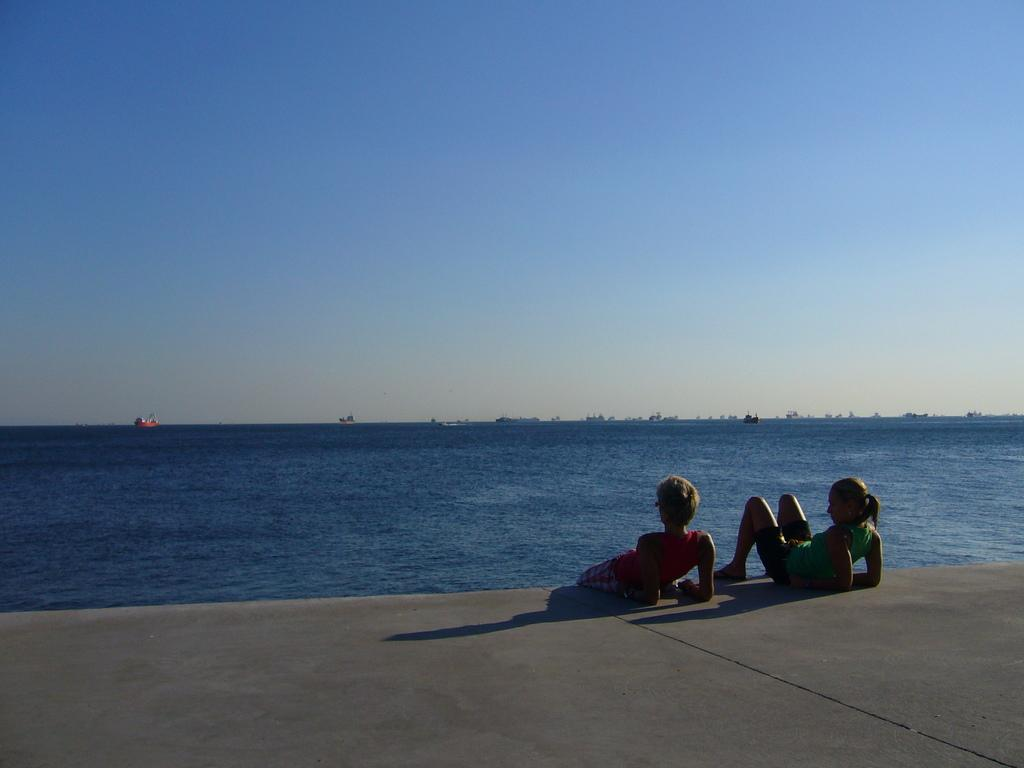What are the two women in the image doing? The two women are lying on the ground in the image. What can be seen in the background of the image? There are many boats visible in the background on a river. What is visible at the top of the image? The sky is visible at the top of the image. What type of ear can be seen on the fowl in the image? There is no fowl or ear present in the image. How many hens are visible in the image? There are no hens present in the image. 